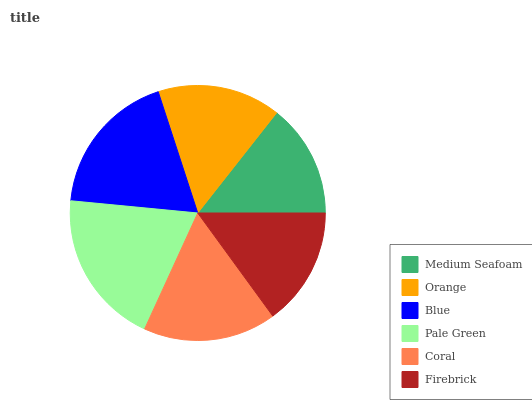Is Medium Seafoam the minimum?
Answer yes or no. Yes. Is Pale Green the maximum?
Answer yes or no. Yes. Is Orange the minimum?
Answer yes or no. No. Is Orange the maximum?
Answer yes or no. No. Is Orange greater than Medium Seafoam?
Answer yes or no. Yes. Is Medium Seafoam less than Orange?
Answer yes or no. Yes. Is Medium Seafoam greater than Orange?
Answer yes or no. No. Is Orange less than Medium Seafoam?
Answer yes or no. No. Is Coral the high median?
Answer yes or no. Yes. Is Orange the low median?
Answer yes or no. Yes. Is Medium Seafoam the high median?
Answer yes or no. No. Is Firebrick the low median?
Answer yes or no. No. 